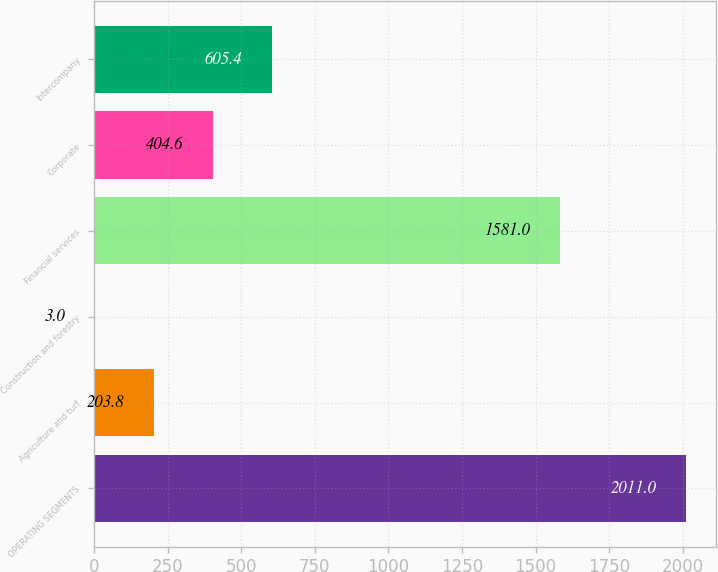<chart> <loc_0><loc_0><loc_500><loc_500><bar_chart><fcel>OPERATING SEGMENTS<fcel>Agriculture and turf<fcel>Construction and forestry<fcel>Financial services<fcel>Corporate<fcel>Intercompany<nl><fcel>2011<fcel>203.8<fcel>3<fcel>1581<fcel>404.6<fcel>605.4<nl></chart> 